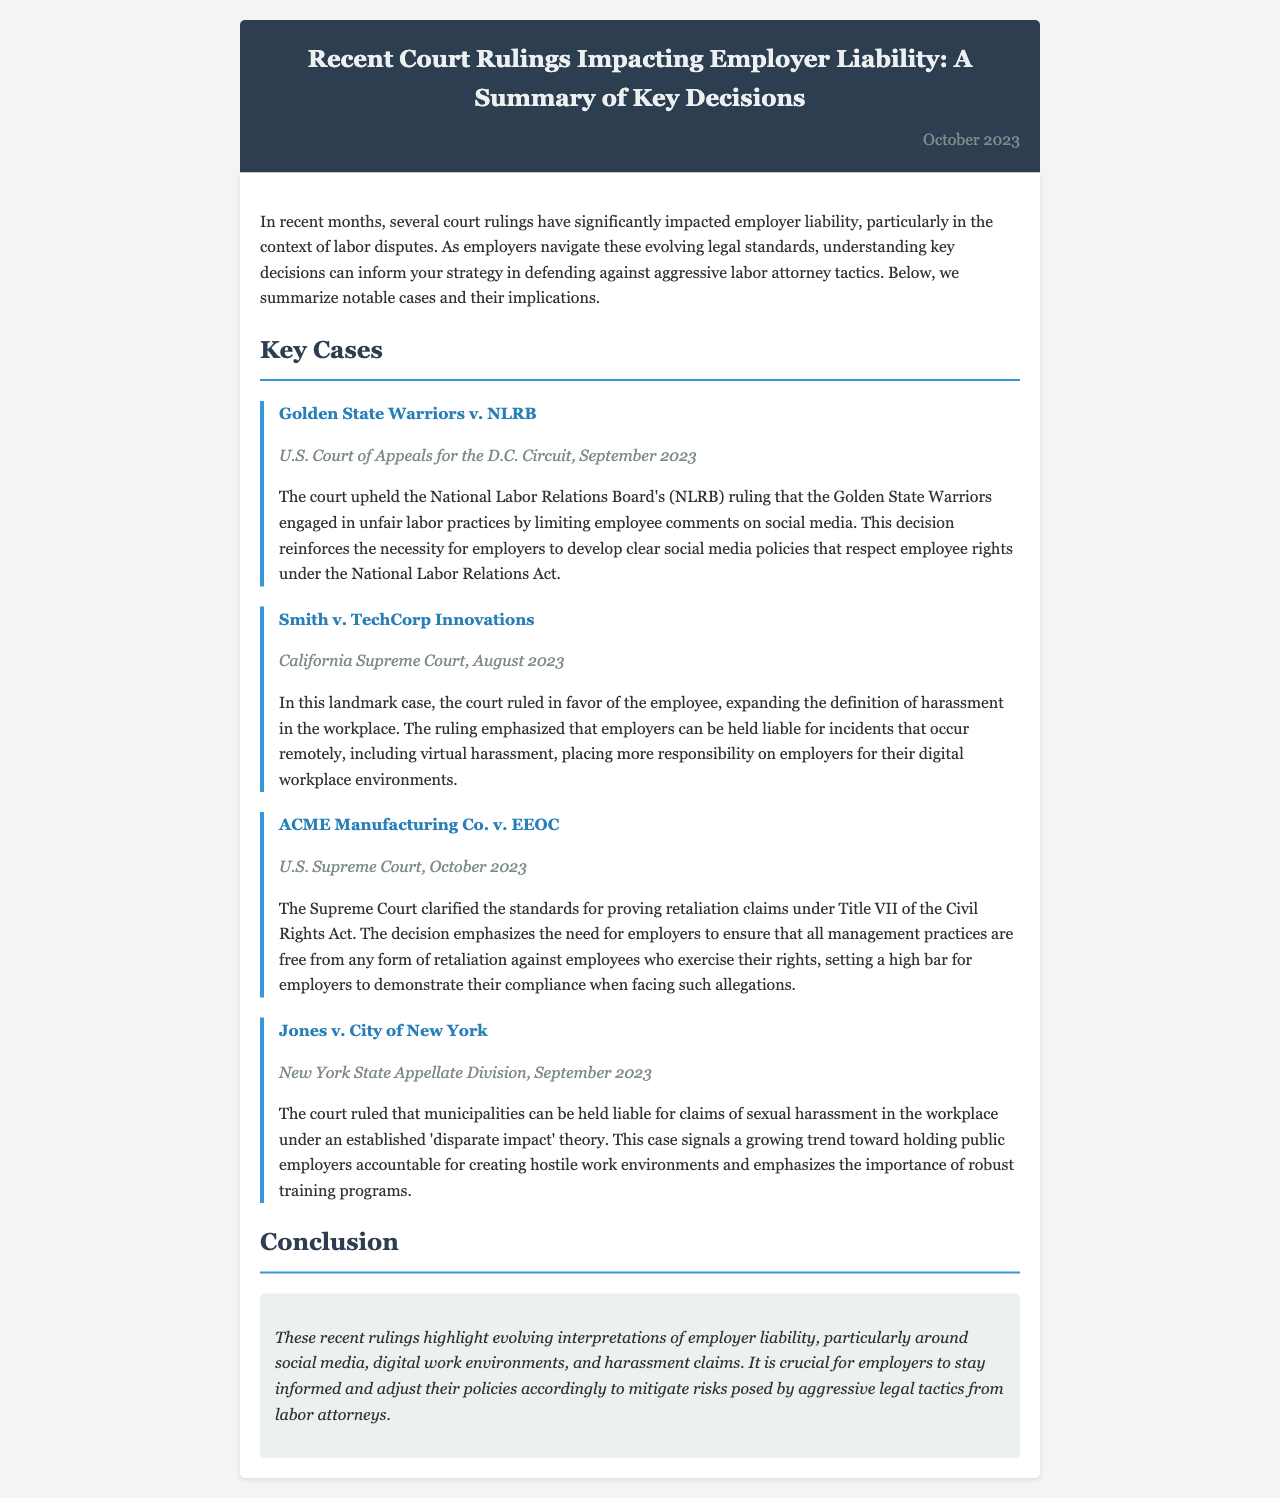What was the ruling in Golden State Warriors v. NLRB? The court upheld the NLRB's ruling that the Golden State Warriors engaged in unfair labor practices by limiting employee comments on social media.
Answer: Unfair labor practices Which court ruled on Smith v. TechCorp Innovations? The California Supreme Court ruled on this case in August 2023.
Answer: California Supreme Court What key issue did the U.S. Supreme Court address in ACME Manufacturing Co. v. EEOC? The Supreme Court clarified the standards for proving retaliation claims under Title VII of the Civil Rights Act.
Answer: Retaliation claims When did the New York State Appellate Division rule on Jones v. City of New York? The ruling was made in September 2023.
Answer: September 2023 What expanded definition was emphasized in the ruling of Smith v. TechCorp Innovations? The ruling expanded the definition of harassment in the workplace.
Answer: Harassment What trend was indicated by the ruling in Jones v. City of New York regarding municipalities? The court ruled that municipalities can be held liable for claims of sexual harassment in the workplace under an established 'disparate impact' theory.
Answer: Liability for sexual harassment What should employers do in light of recent court rulings? Employers should stay informed and adjust their policies accordingly.
Answer: Adjust policies What is the general theme of the recent court rulings discussed in the newsletter? The rulings highlight evolving interpretations of employer liability.
Answer: Employer liability 